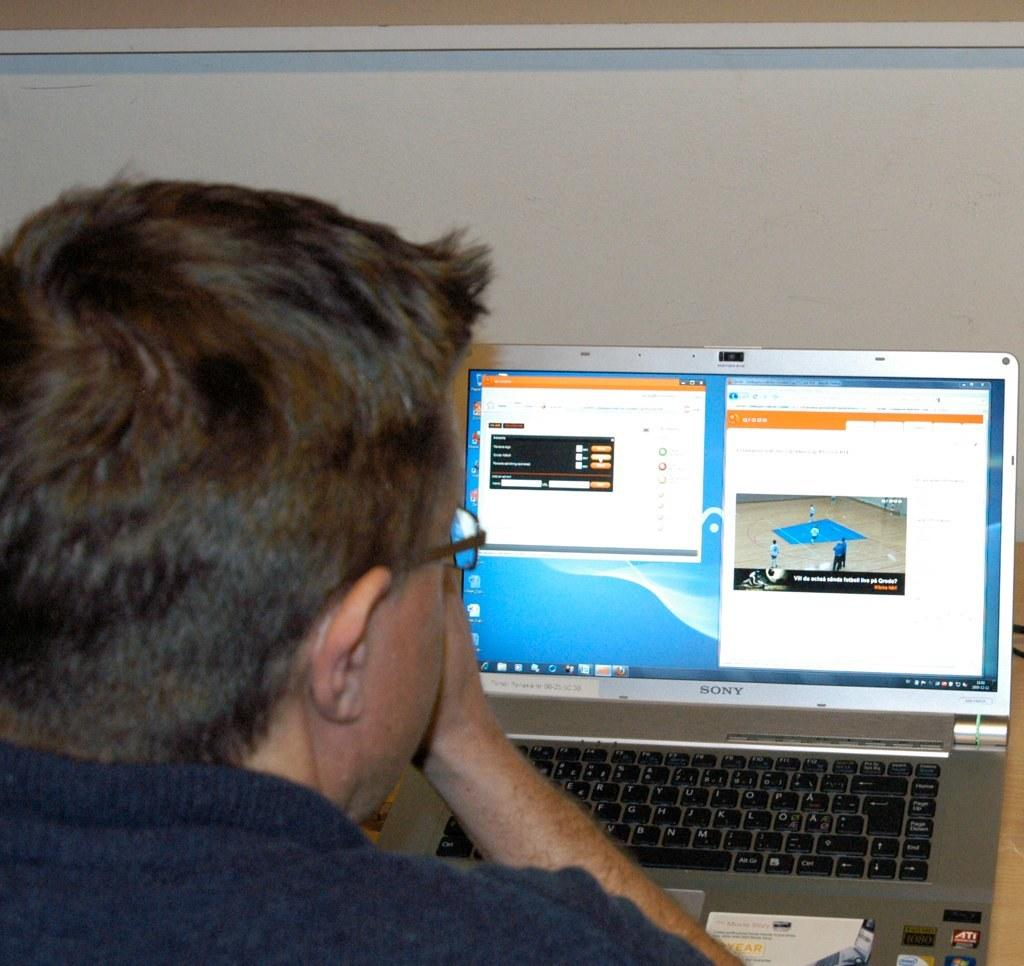<image>
Summarize the visual content of the image. Man using a silver Sony laptop while watching basketball. 